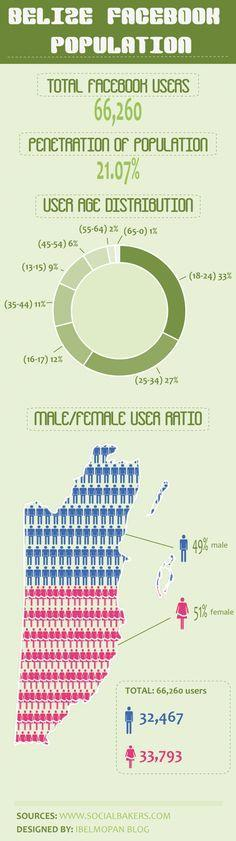What is the difference between female users and male users?
Answer the question with a short phrase. 1326 What is the difference between female users and male users in percentage? 2% What is the difference between users with the age group of 18-24 and 25-34? 6% 